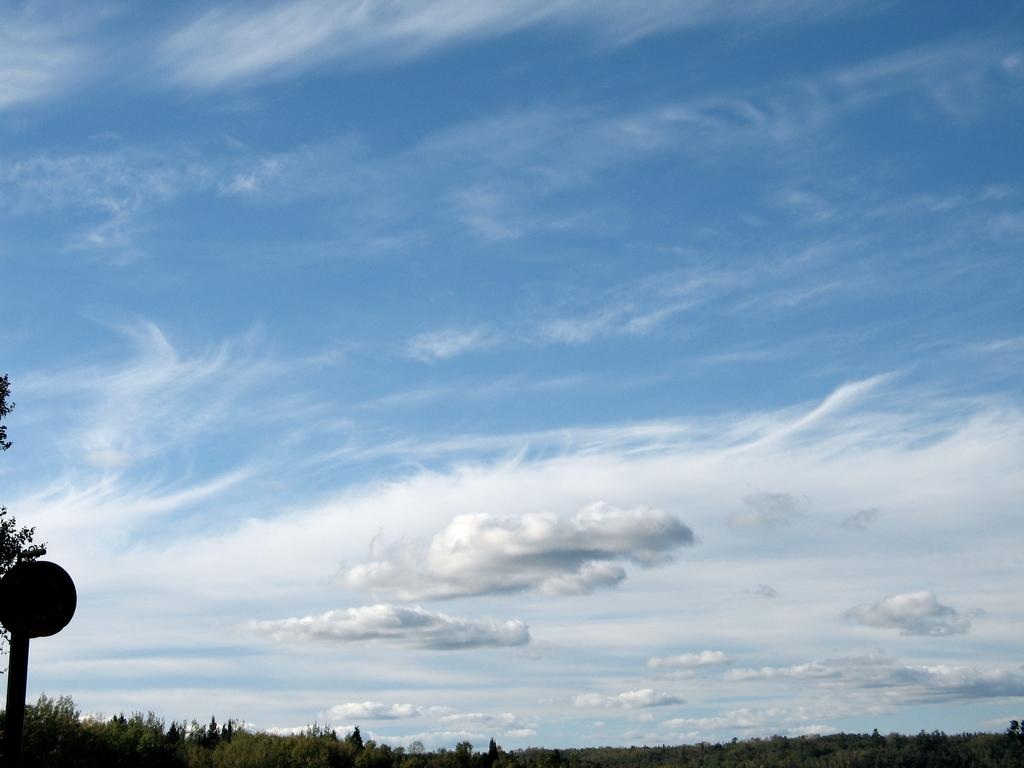What type of natural elements can be seen in the image? There are trees and clouds in the image. Can you describe the object on the left side of the image? Unfortunately, the facts provided do not give any details about the object on the left side of the image. What is the weather like in the image? The presence of clouds suggests that the weather might be partly cloudy, but the facts do not give any specific information about the weather. What is the price of the scissors in the image? There are no scissors present in the image, so it is not possible to determine their price. 